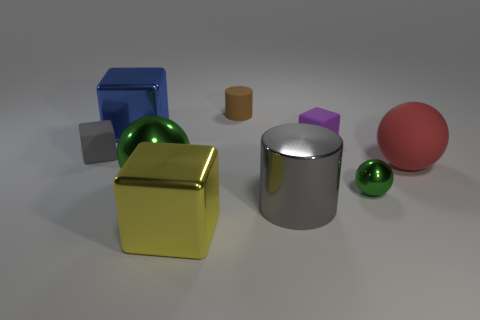Is there a large green object that has the same shape as the large gray object?
Your response must be concise. No. There is a cylinder in front of the gray thing that is behind the rubber sphere; how big is it?
Your response must be concise. Large. The large object that is on the left side of the green metallic thing to the left of the big metallic cube in front of the blue shiny block is what shape?
Offer a very short reply. Cube. There is a red ball that is made of the same material as the tiny purple block; what size is it?
Your response must be concise. Large. Is the number of small cyan matte objects greater than the number of large yellow things?
Ensure brevity in your answer.  No. There is a yellow cube that is the same size as the gray shiny thing; what is its material?
Make the answer very short. Metal. There is a purple thing that is on the right side of the blue metal cube; does it have the same size as the large gray thing?
Your response must be concise. No. What number of cubes are large blue things or rubber objects?
Provide a succinct answer. 3. What is the material of the cylinder that is in front of the large blue cube?
Your response must be concise. Metal. Are there fewer gray rubber cubes than small green matte objects?
Your response must be concise. No. 